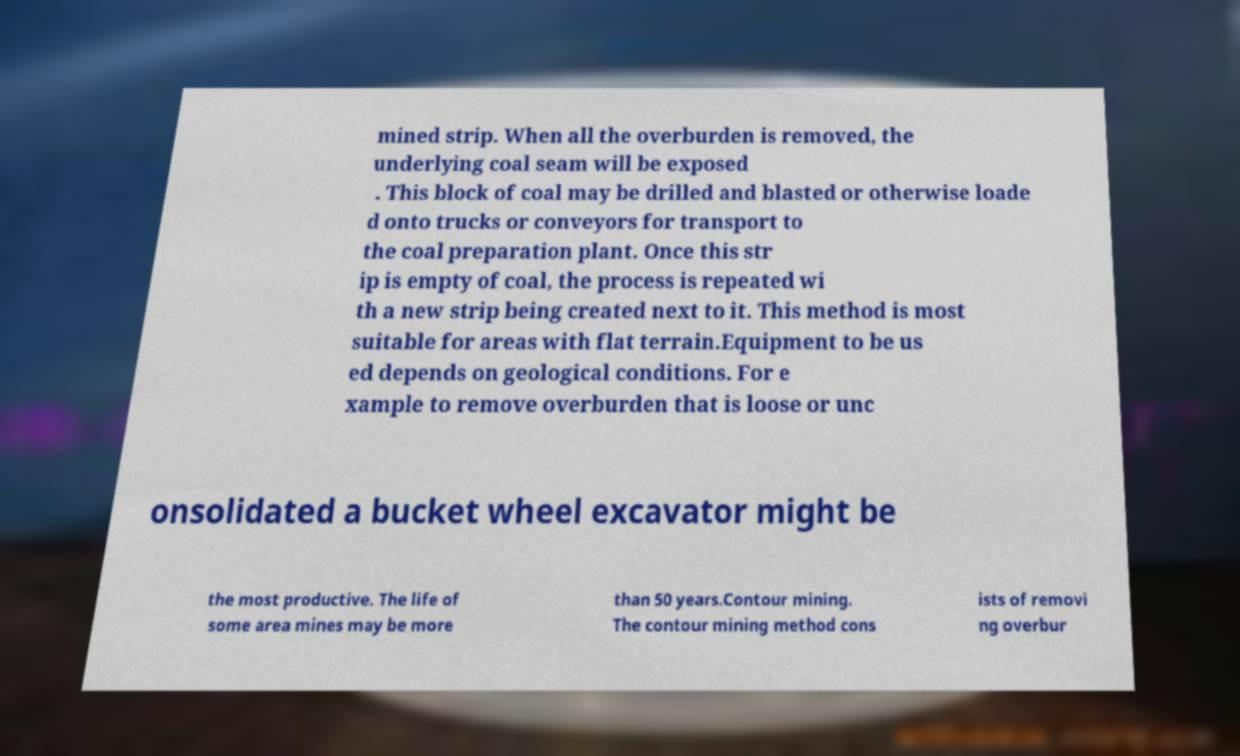Could you assist in decoding the text presented in this image and type it out clearly? mined strip. When all the overburden is removed, the underlying coal seam will be exposed . This block of coal may be drilled and blasted or otherwise loade d onto trucks or conveyors for transport to the coal preparation plant. Once this str ip is empty of coal, the process is repeated wi th a new strip being created next to it. This method is most suitable for areas with flat terrain.Equipment to be us ed depends on geological conditions. For e xample to remove overburden that is loose or unc onsolidated a bucket wheel excavator might be the most productive. The life of some area mines may be more than 50 years.Contour mining. The contour mining method cons ists of removi ng overbur 